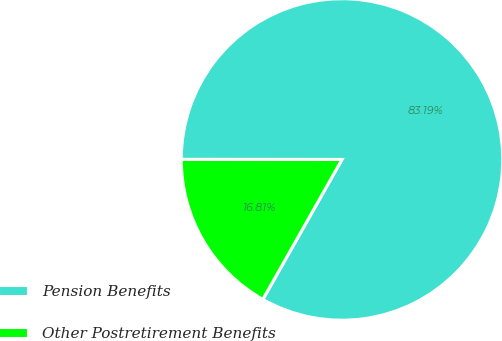<chart> <loc_0><loc_0><loc_500><loc_500><pie_chart><fcel>Pension Benefits<fcel>Other Postretirement Benefits<nl><fcel>83.19%<fcel>16.81%<nl></chart> 